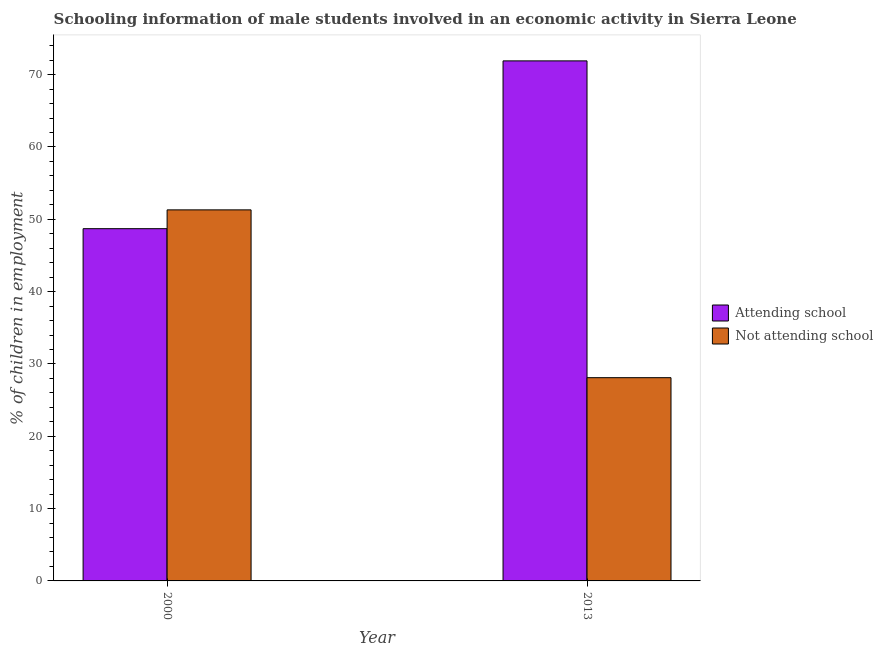Are the number of bars per tick equal to the number of legend labels?
Provide a succinct answer. Yes. Are the number of bars on each tick of the X-axis equal?
Ensure brevity in your answer.  Yes. How many bars are there on the 1st tick from the left?
Your answer should be compact. 2. What is the percentage of employed males who are not attending school in 2000?
Your answer should be very brief. 51.3. Across all years, what is the maximum percentage of employed males who are not attending school?
Your answer should be compact. 51.3. Across all years, what is the minimum percentage of employed males who are not attending school?
Give a very brief answer. 28.1. What is the total percentage of employed males who are attending school in the graph?
Your answer should be compact. 120.6. What is the difference between the percentage of employed males who are not attending school in 2000 and that in 2013?
Your answer should be very brief. 23.2. What is the difference between the percentage of employed males who are attending school in 2013 and the percentage of employed males who are not attending school in 2000?
Offer a terse response. 23.2. What is the average percentage of employed males who are attending school per year?
Provide a short and direct response. 60.3. What is the ratio of the percentage of employed males who are attending school in 2000 to that in 2013?
Offer a terse response. 0.68. In how many years, is the percentage of employed males who are attending school greater than the average percentage of employed males who are attending school taken over all years?
Provide a short and direct response. 1. What does the 2nd bar from the left in 2000 represents?
Make the answer very short. Not attending school. What does the 1st bar from the right in 2013 represents?
Your answer should be compact. Not attending school. How many years are there in the graph?
Make the answer very short. 2. What is the difference between two consecutive major ticks on the Y-axis?
Offer a terse response. 10. Where does the legend appear in the graph?
Ensure brevity in your answer.  Center right. What is the title of the graph?
Offer a terse response. Schooling information of male students involved in an economic activity in Sierra Leone. Does "Enforce a contract" appear as one of the legend labels in the graph?
Your answer should be compact. No. What is the label or title of the Y-axis?
Keep it short and to the point. % of children in employment. What is the % of children in employment of Attending school in 2000?
Provide a succinct answer. 48.7. What is the % of children in employment of Not attending school in 2000?
Your answer should be compact. 51.3. What is the % of children in employment in Attending school in 2013?
Offer a very short reply. 71.9. What is the % of children in employment in Not attending school in 2013?
Make the answer very short. 28.1. Across all years, what is the maximum % of children in employment of Attending school?
Offer a very short reply. 71.9. Across all years, what is the maximum % of children in employment of Not attending school?
Your answer should be compact. 51.3. Across all years, what is the minimum % of children in employment of Attending school?
Provide a succinct answer. 48.7. Across all years, what is the minimum % of children in employment in Not attending school?
Your response must be concise. 28.1. What is the total % of children in employment in Attending school in the graph?
Offer a terse response. 120.6. What is the total % of children in employment of Not attending school in the graph?
Your response must be concise. 79.4. What is the difference between the % of children in employment of Attending school in 2000 and that in 2013?
Provide a short and direct response. -23.2. What is the difference between the % of children in employment in Not attending school in 2000 and that in 2013?
Your response must be concise. 23.2. What is the difference between the % of children in employment of Attending school in 2000 and the % of children in employment of Not attending school in 2013?
Give a very brief answer. 20.6. What is the average % of children in employment in Attending school per year?
Offer a terse response. 60.3. What is the average % of children in employment of Not attending school per year?
Your answer should be compact. 39.7. In the year 2000, what is the difference between the % of children in employment in Attending school and % of children in employment in Not attending school?
Your answer should be compact. -2.6. In the year 2013, what is the difference between the % of children in employment of Attending school and % of children in employment of Not attending school?
Provide a short and direct response. 43.8. What is the ratio of the % of children in employment in Attending school in 2000 to that in 2013?
Give a very brief answer. 0.68. What is the ratio of the % of children in employment in Not attending school in 2000 to that in 2013?
Ensure brevity in your answer.  1.83. What is the difference between the highest and the second highest % of children in employment of Attending school?
Offer a terse response. 23.2. What is the difference between the highest and the second highest % of children in employment of Not attending school?
Ensure brevity in your answer.  23.2. What is the difference between the highest and the lowest % of children in employment in Attending school?
Give a very brief answer. 23.2. What is the difference between the highest and the lowest % of children in employment of Not attending school?
Make the answer very short. 23.2. 